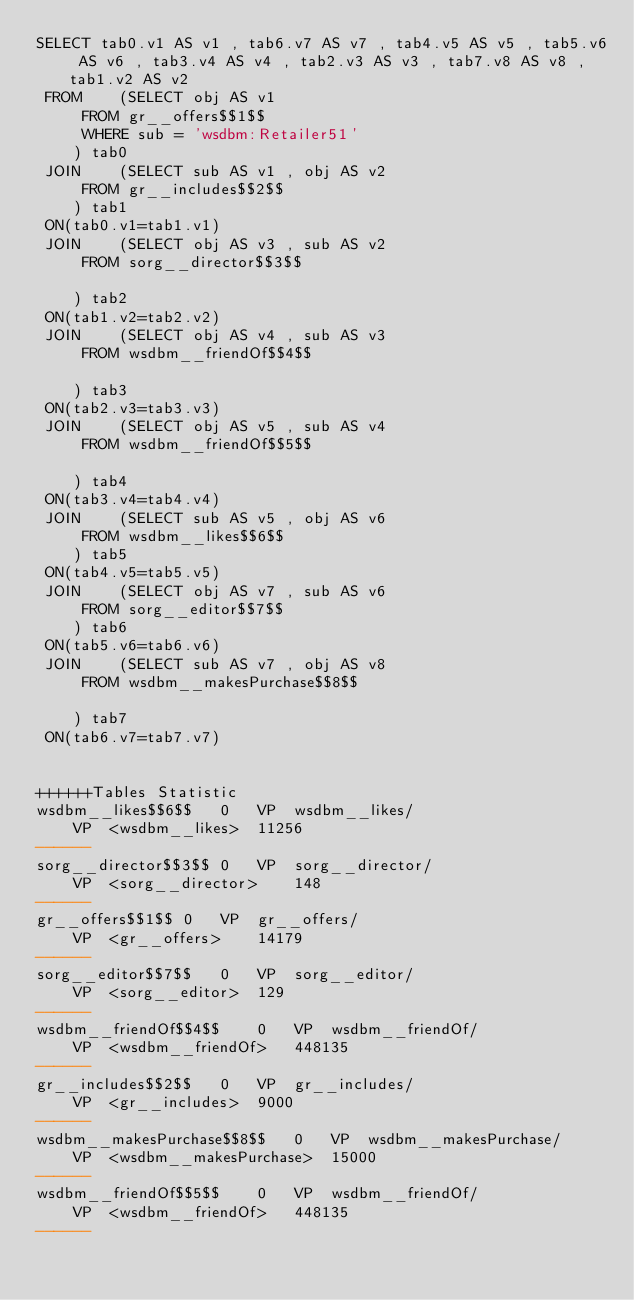<code> <loc_0><loc_0><loc_500><loc_500><_SQL_>SELECT tab0.v1 AS v1 , tab6.v7 AS v7 , tab4.v5 AS v5 , tab5.v6 AS v6 , tab3.v4 AS v4 , tab2.v3 AS v3 , tab7.v8 AS v8 , tab1.v2 AS v2 
 FROM    (SELECT obj AS v1 
	 FROM gr__offers$$1$$ 
	 WHERE sub = 'wsdbm:Retailer51'
	) tab0
 JOIN    (SELECT sub AS v1 , obj AS v2 
	 FROM gr__includes$$2$$
	) tab1
 ON(tab0.v1=tab1.v1)
 JOIN    (SELECT obj AS v3 , sub AS v2 
	 FROM sorg__director$$3$$
	
	) tab2
 ON(tab1.v2=tab2.v2)
 JOIN    (SELECT obj AS v4 , sub AS v3 
	 FROM wsdbm__friendOf$$4$$
	
	) tab3
 ON(tab2.v3=tab3.v3)
 JOIN    (SELECT obj AS v5 , sub AS v4 
	 FROM wsdbm__friendOf$$5$$
	
	) tab4
 ON(tab3.v4=tab4.v4)
 JOIN    (SELECT sub AS v5 , obj AS v6 
	 FROM wsdbm__likes$$6$$
	) tab5
 ON(tab4.v5=tab5.v5)
 JOIN    (SELECT obj AS v7 , sub AS v6 
	 FROM sorg__editor$$7$$
	) tab6
 ON(tab5.v6=tab6.v6)
 JOIN    (SELECT sub AS v7 , obj AS v8 
	 FROM wsdbm__makesPurchase$$8$$
	
	) tab7
 ON(tab6.v7=tab7.v7)


++++++Tables Statistic
wsdbm__likes$$6$$	0	VP	wsdbm__likes/
	VP	<wsdbm__likes>	11256
------
sorg__director$$3$$	0	VP	sorg__director/
	VP	<sorg__director>	148
------
gr__offers$$1$$	0	VP	gr__offers/
	VP	<gr__offers>	14179
------
sorg__editor$$7$$	0	VP	sorg__editor/
	VP	<sorg__editor>	129
------
wsdbm__friendOf$$4$$	0	VP	wsdbm__friendOf/
	VP	<wsdbm__friendOf>	448135
------
gr__includes$$2$$	0	VP	gr__includes/
	VP	<gr__includes>	9000
------
wsdbm__makesPurchase$$8$$	0	VP	wsdbm__makesPurchase/
	VP	<wsdbm__makesPurchase>	15000
------
wsdbm__friendOf$$5$$	0	VP	wsdbm__friendOf/
	VP	<wsdbm__friendOf>	448135
------
</code> 